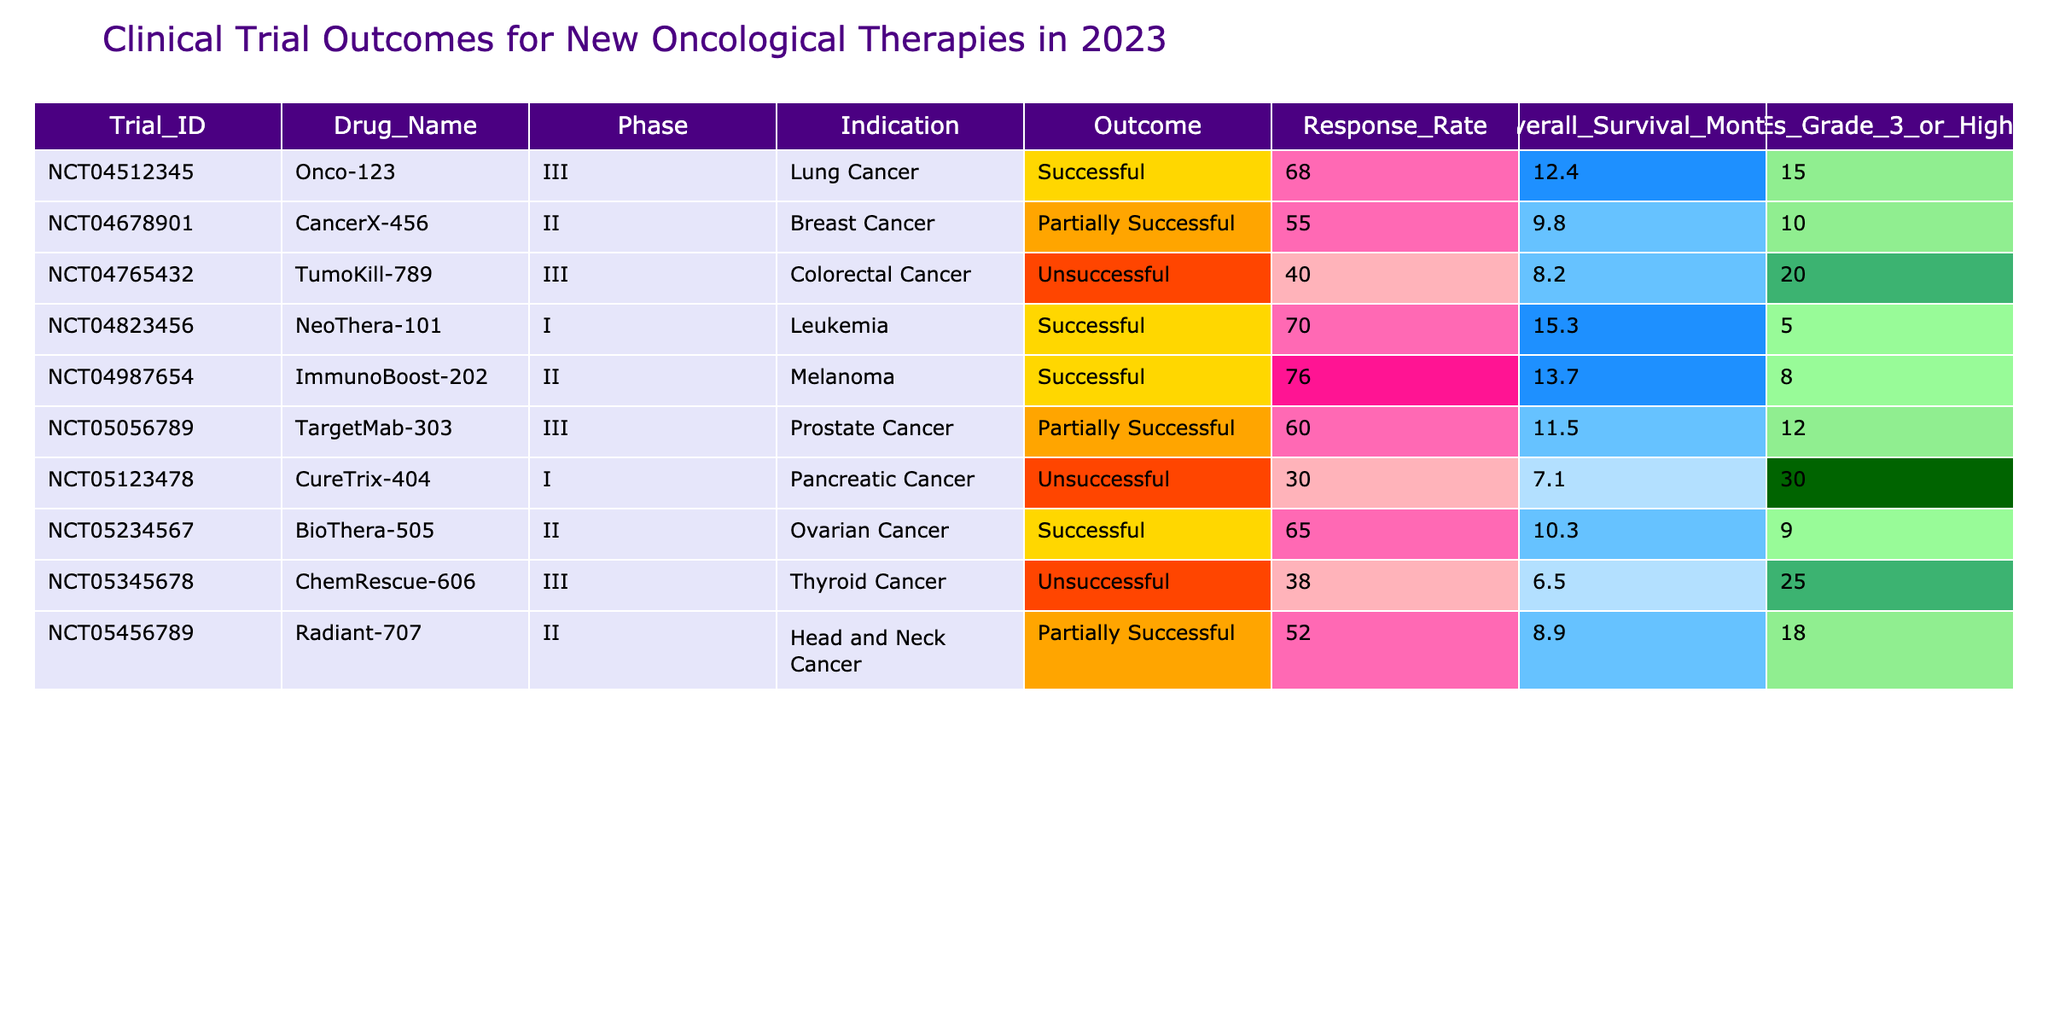What percentage of trials resulted in a successful outcome? Out of the 10 trials listed, 4 trials were marked as successful. To find the percentage, divide the number of successful trials (4) by the total number of trials (10) and multiply by 100. Thus, (4/10) * 100 = 40%.
Answer: 40% Which drug had the highest response rate? By inspecting the response rates, the highest response rate is seen for ImmunoBoost-202, which had a response rate of 76%.
Answer: 76% How many trials had a Grade 3 or higher adverse event rate of 20 or more? Looking at the column for adverse events, there are 3 trials where the Grade 3 or higher adverse events are 20 or more: TumoKill-789 (20), ChemRescue-606 (25), and CureTrix-404 (30).
Answer: 3 What is the average overall survival months of the successful trials? The overall survival months for the successful trials are: 12.4 (Onco-123), 15.3 (NeoThera-101), 13.7 (ImmunoBoost-202), and 10.3 (BioThera-505). Summing them gives 12.4 + 15.3 + 13.7 + 10.3 = 51.7. Dividing by the number of successful trials (4) then gives an average of 51.7/4 = 12.93 months.
Answer: 12.93 months Which trial had the lowest overall survival months and what was its outcome? The trial with the lowest overall survival months is CureTrix-404, which had an overall survival of 7.1 months and was marked as unsuccessful.
Answer: CureTrix-404, Unsuccessful Is it true that all Phase I trials were successful? There are two Phase I trials listed: NeoThera-101 (Successful) and CureTrix-404 (Unsuccessful). Since one of them is unsuccessful, it is false that all Phase I trials were successful.
Answer: False What is the difference in response rate between the highest and lowest response rates? The highest response rate is from ImmunoBoost-202 at 76%, and the lowest is from CureTrix-404 at 30%. The difference is calculated as 76 - 30 = 46%.
Answer: 46% Are there more trials with a partially successful outcome or an unsuccessful outcome? There are 3 trials marked as partially successful (CancerX-456, TargetMab-303, and Radiant-707) compared to 4 trials that are marked as unsuccessful (TumoKill-789, CureTrix-404, ChemRescue-606). Since 4 is greater than 3, there are more unsuccessful trials.
Answer: More unsuccessful outcomes Which drug in the table had the longest overall survival and what was the indication? The longest overall survival is for NeoThera-101 with an overall survival of 15.3 months, and it is indicated for leukemia.
Answer: NeoThera-101, Leukemia If we consider only the successful drugs, what is the median response rate? The response rates for successful drugs are: 68% (Onco-123), 70% (NeoThera-101), 76% (ImmunoBoost-202), and 65% (BioThera-505). Arranging these gives: 65, 68, 70, 76. The median is the average of the two middle values (68 and 70), which is (68+70)/2 = 69%.
Answer: 69% 